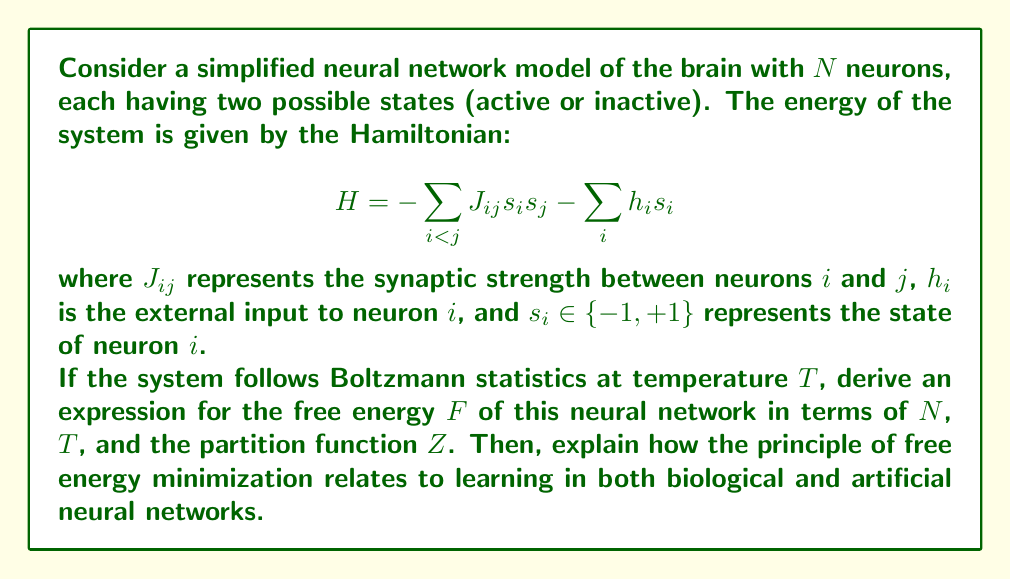Could you help me with this problem? Let's approach this step-by-step:

1) The free energy $F$ is defined as:

   $$F = U - TS$$

   where $U$ is the internal energy, $T$ is the temperature, and $S$ is the entropy.

2) In statistical mechanics, we can express $F$ in terms of the partition function $Z$:

   $$F = -kT \ln Z$$

   where $k$ is the Boltzmann constant.

3) For our system with $N$ neurons, each with two possible states, there are $2^N$ possible configurations. The partition function $Z$ is the sum over all these configurations:

   $$Z = \sum_{\{s_i\}} e^{-\beta H}$$

   where $\beta = \frac{1}{kT}$ and the sum is over all possible configurations of $\{s_i\}$.

4) Substituting this into our expression for $F$:

   $$F = -kT \ln \left(\sum_{\{s_i\}} e^{-\beta H}\right)$$

5) This is our final expression for the free energy of the neural network.

6) The principle of free energy minimization states that a system will naturally evolve towards a state that minimizes its free energy. In the context of neural networks:

   a) For biological neural networks, this principle can be interpreted as the brain's tendency to minimize surprise or prediction error. The brain forms internal models of the world and updates these models to better predict sensory inputs, thereby minimizing free energy.

   b) In artificial neural networks, the learning process can be framed as minimizing a loss function, which is analogous to minimizing free energy. The weights of the network (analogous to $J_{ij}$ in our model) are adjusted to minimize this loss, improving the network's ability to predict or classify inputs.

7) In both cases, the system (biological or artificial) is trying to find an optimal balance between fitting the data (minimizing energy) and maintaining flexibility (maximizing entropy), which is exactly what free energy minimization achieves.
Answer: $$F = -kT \ln \left(\sum_{\{s_i\}} e^{-\beta H}\right)$$
Free energy minimization in neural networks balances data fitting and model flexibility, guiding learning in both biological and artificial systems. 